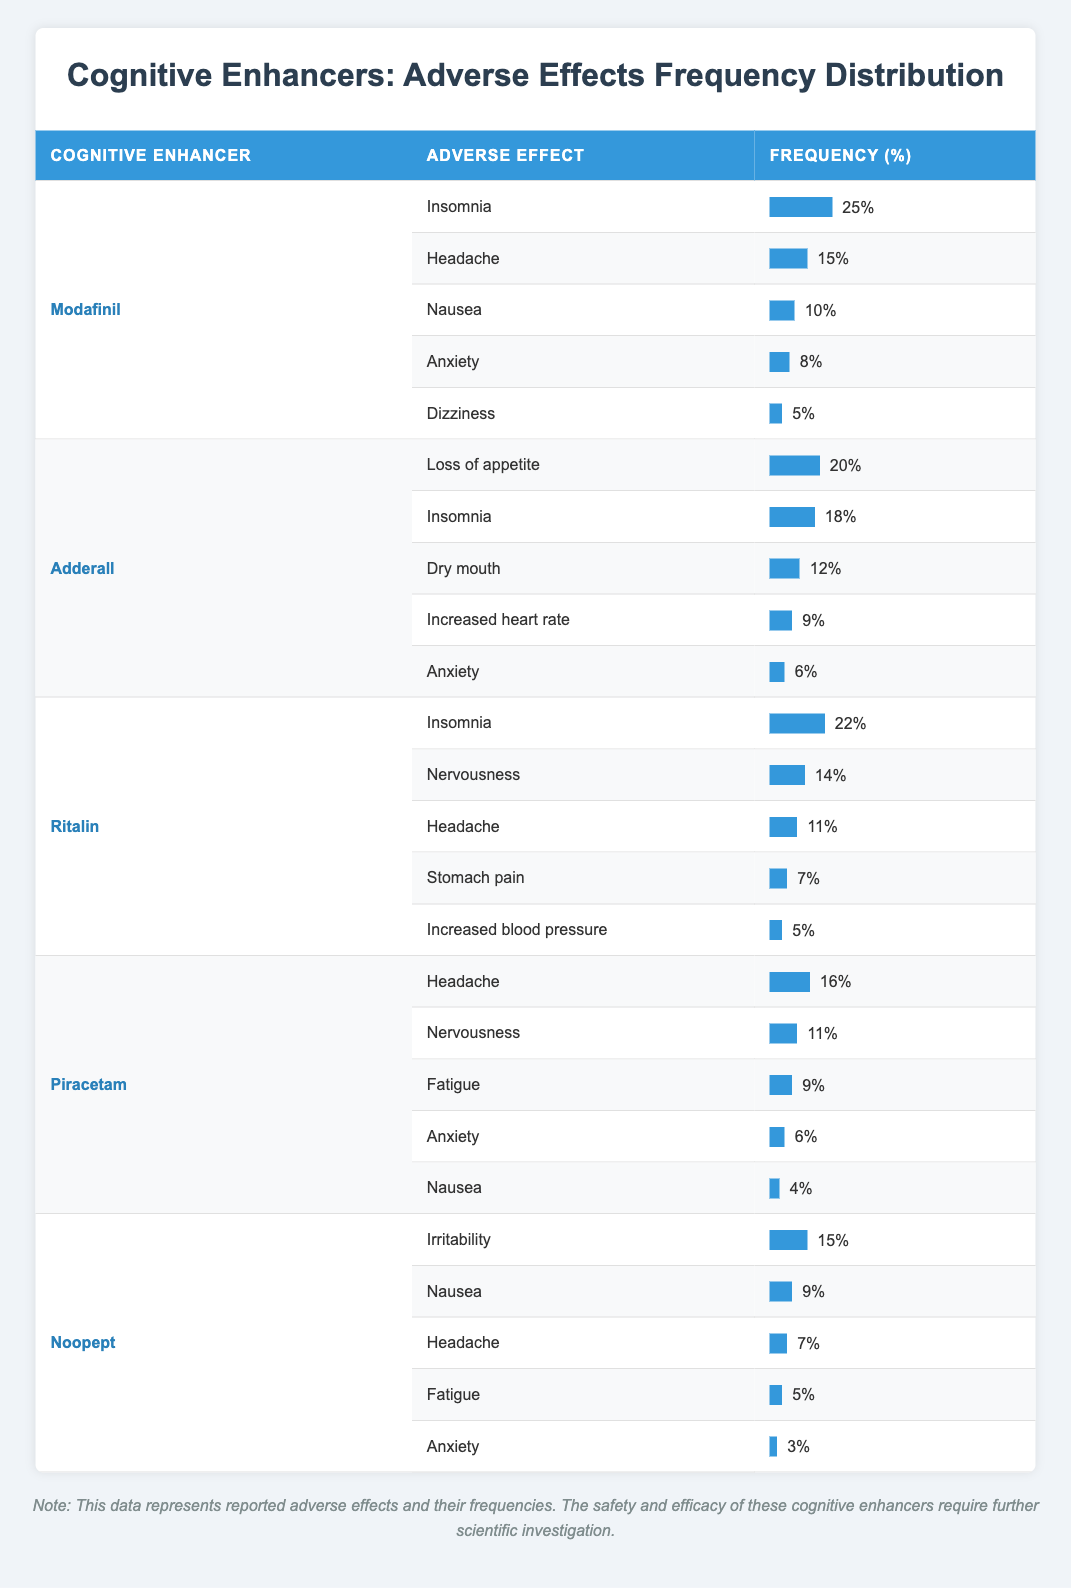What is the most frequently reported adverse effect for Modafinil? The table shows the adverse effects for Modafinil. The frequency for Insomnia is 25%, which is higher than any other reported effect for this cognitive enhancer.
Answer: Insomnia How many adverse effects were reported for Ritalin? Looking at the table, Ritalin has five adverse effects listed: Insomnia, Nervousness, Headache, Stomach pain, and Increased blood pressure.
Answer: 5 What is the average percentage of reported adverse effects for Noopept? Noopept has five adverse effects with the following frequencies: 15%, 9%, 7%, 5%, and 3%. The sum of these frequencies is 39%. Dividing by the number of effects (5) gives an average of 7.8%.
Answer: 7.8% Is anxiety reported as an adverse effect for all cognitive enhancers listed? By reviewing the table, Anxiety is reported as an adverse effect for Modafinil, Adderall, Ritalin, Piracetam, and Noopept. This confirms that it is listed for all the mentioned cognitive enhancers.
Answer: Yes Which cognitive enhancer has the highest frequency of reporting adverse effects related to insomnia? The table indicates that Ritalin has a frequency of 22% for Insomnia, which is lower than Modafinil's 25%. However, Ritalin's Insomnia effect is still quite high. By comparing these frequencies across enhancers, Modafinil indeed has the highest frequency for insomnia.
Answer: Modafinil 